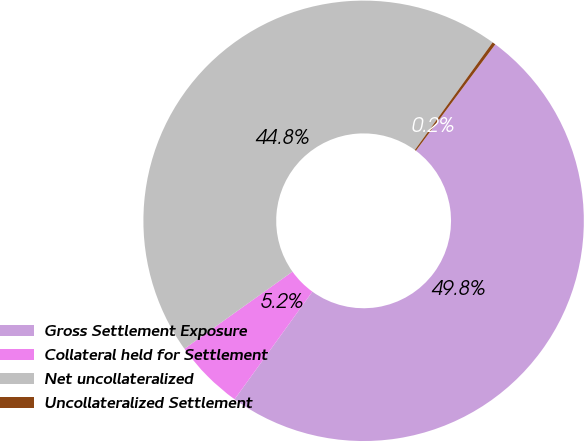Convert chart to OTSL. <chart><loc_0><loc_0><loc_500><loc_500><pie_chart><fcel>Gross Settlement Exposure<fcel>Collateral held for Settlement<fcel>Net uncollateralized<fcel>Uncollateralized Settlement<nl><fcel>49.76%<fcel>5.17%<fcel>44.83%<fcel>0.24%<nl></chart> 